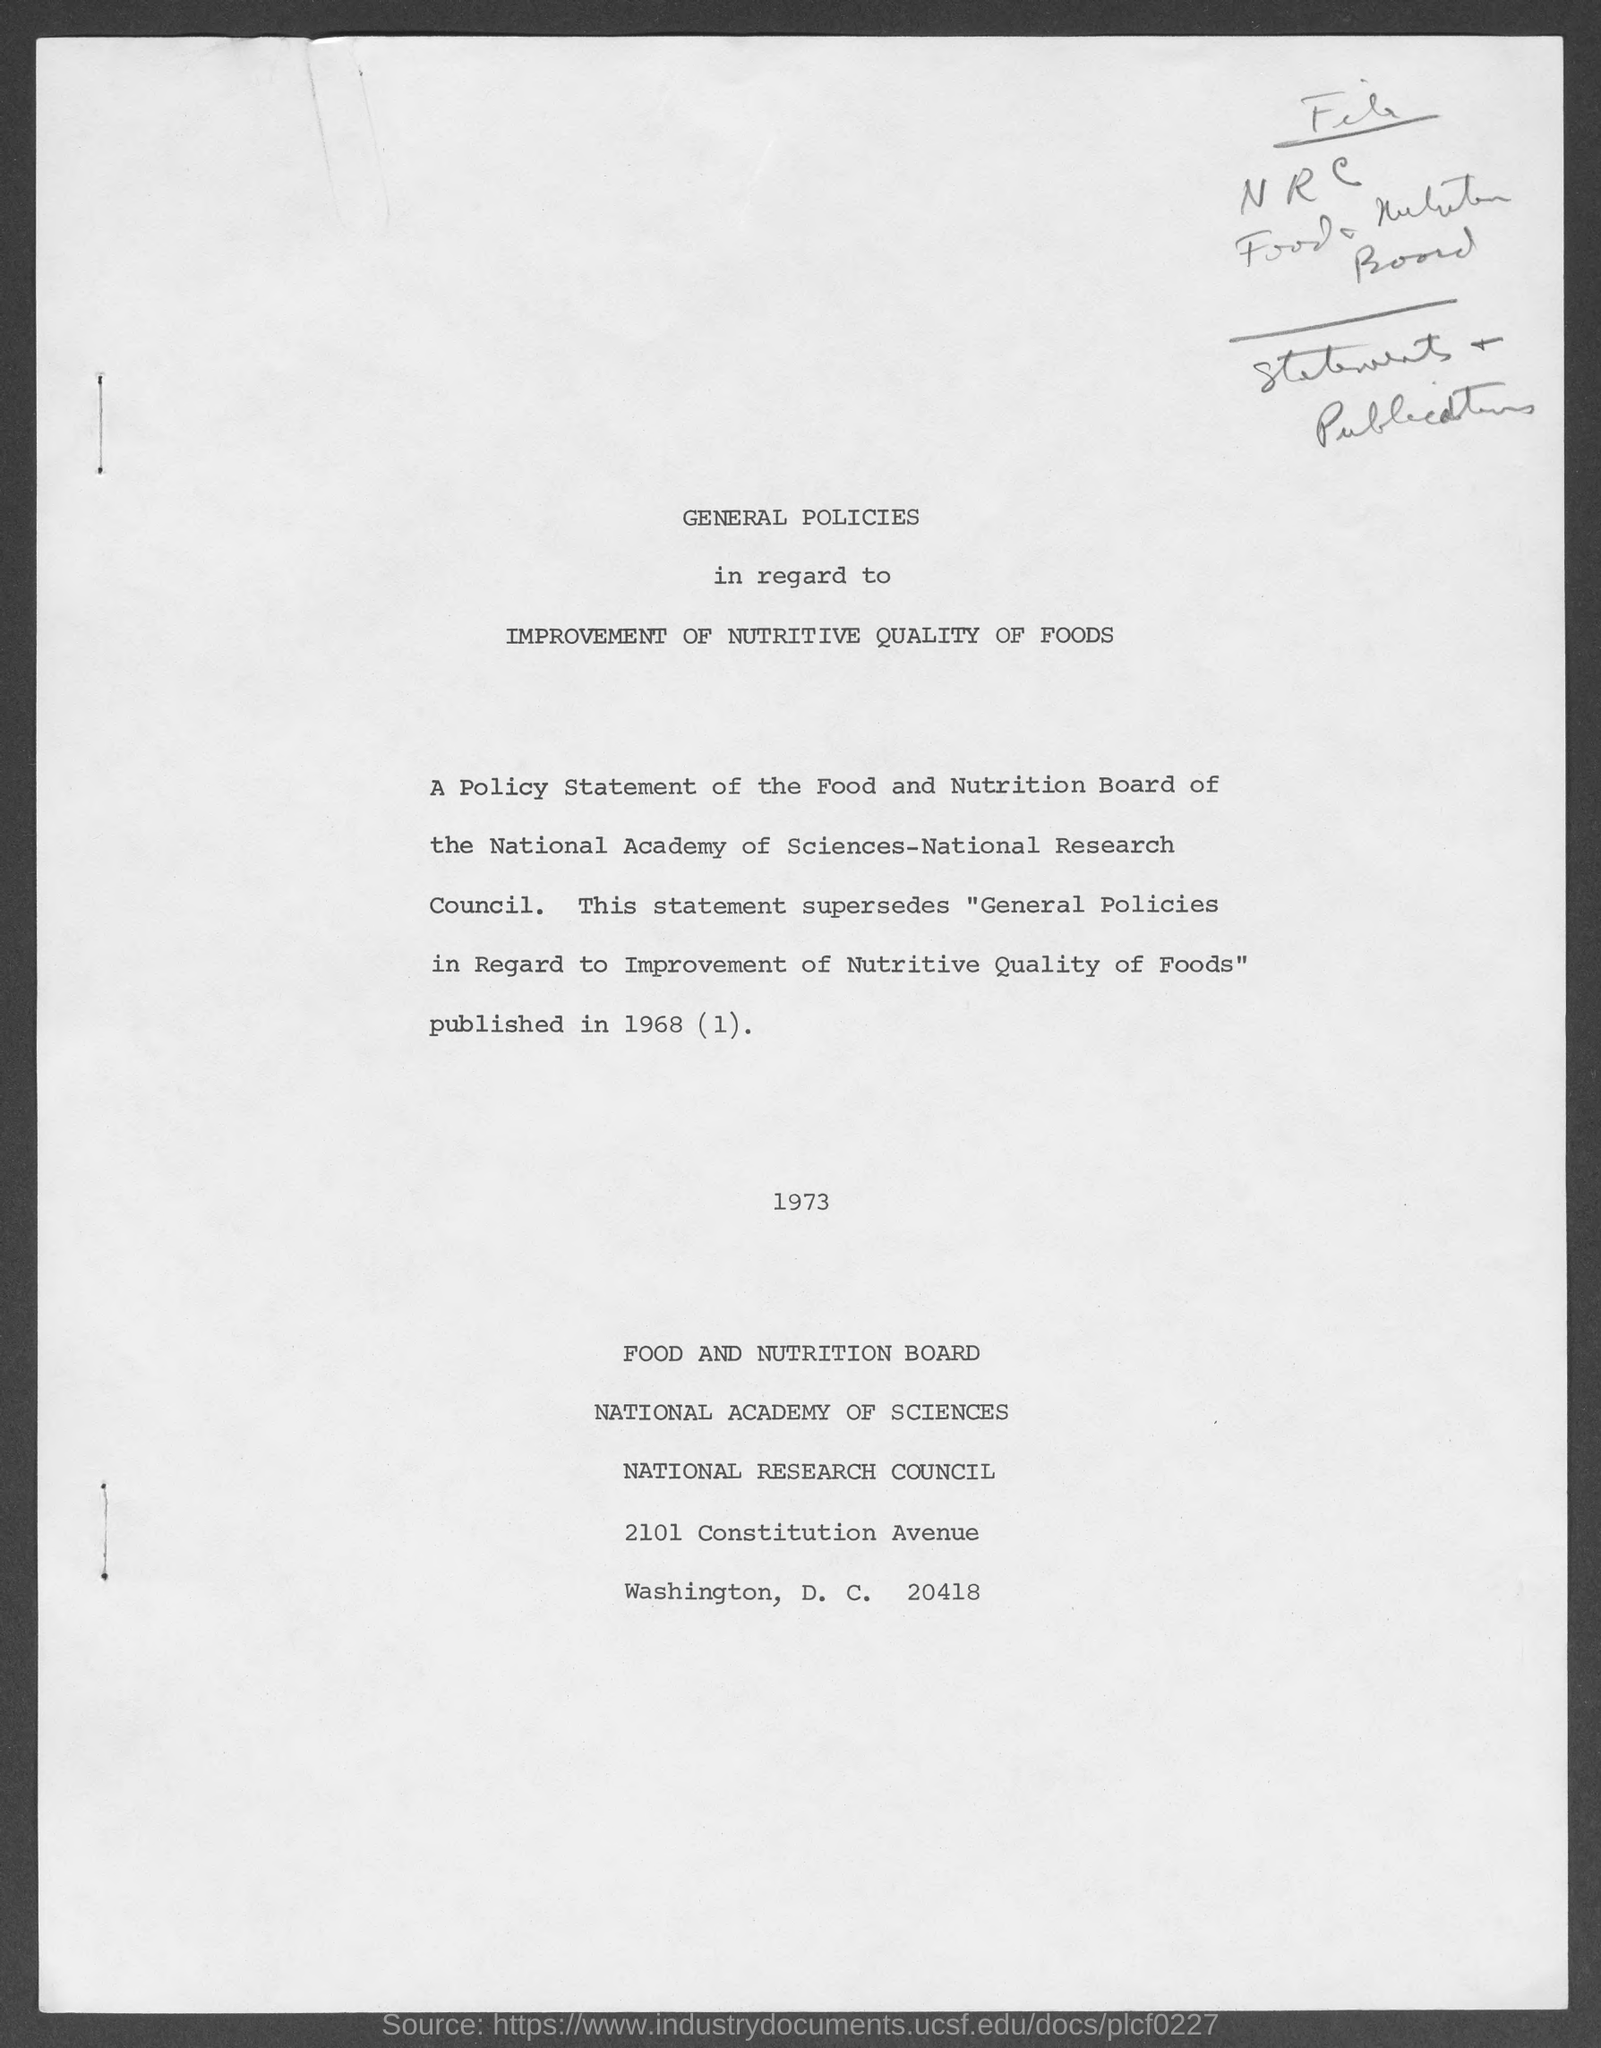What is the street address of food and nutrition board ?
Offer a terse response. 2101 Constitution Avenue. 